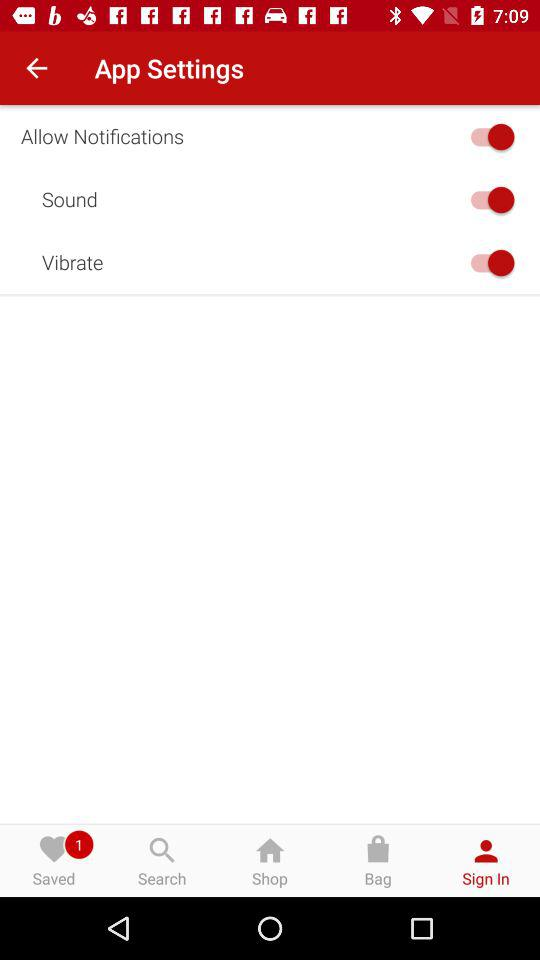How many switches are there in the settings?
Answer the question using a single word or phrase. 3 